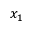Convert formula to latex. <formula><loc_0><loc_0><loc_500><loc_500>x _ { 1 }</formula> 